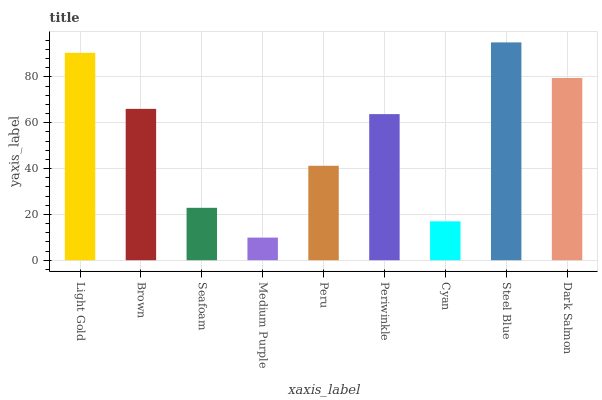Is Medium Purple the minimum?
Answer yes or no. Yes. Is Steel Blue the maximum?
Answer yes or no. Yes. Is Brown the minimum?
Answer yes or no. No. Is Brown the maximum?
Answer yes or no. No. Is Light Gold greater than Brown?
Answer yes or no. Yes. Is Brown less than Light Gold?
Answer yes or no. Yes. Is Brown greater than Light Gold?
Answer yes or no. No. Is Light Gold less than Brown?
Answer yes or no. No. Is Periwinkle the high median?
Answer yes or no. Yes. Is Periwinkle the low median?
Answer yes or no. Yes. Is Medium Purple the high median?
Answer yes or no. No. Is Peru the low median?
Answer yes or no. No. 